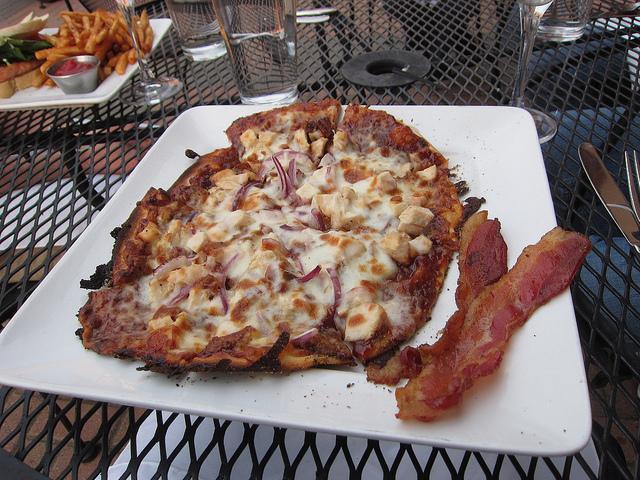Verify the accuracy of this image caption: "The pizza is touching the sandwich.".
Answer yes or no. No. Does the description: "The pizza is in front of the sandwich." accurately reflect the image?
Answer yes or no. Yes. 